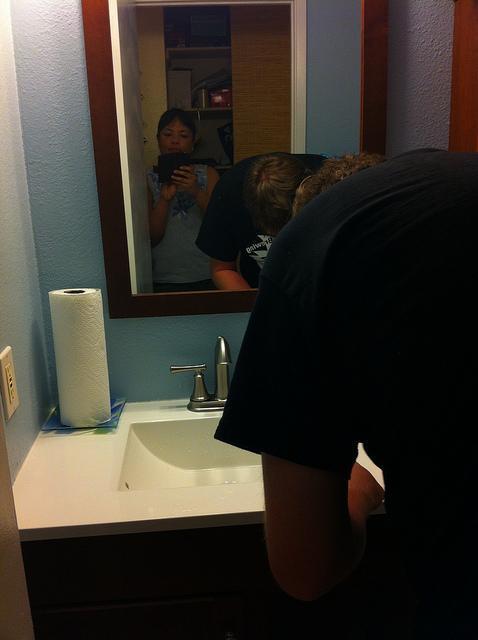How many people are in the mirror?
Give a very brief answer. 2. How many people are there?
Give a very brief answer. 2. 